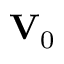<formula> <loc_0><loc_0><loc_500><loc_500>V _ { 0 }</formula> 